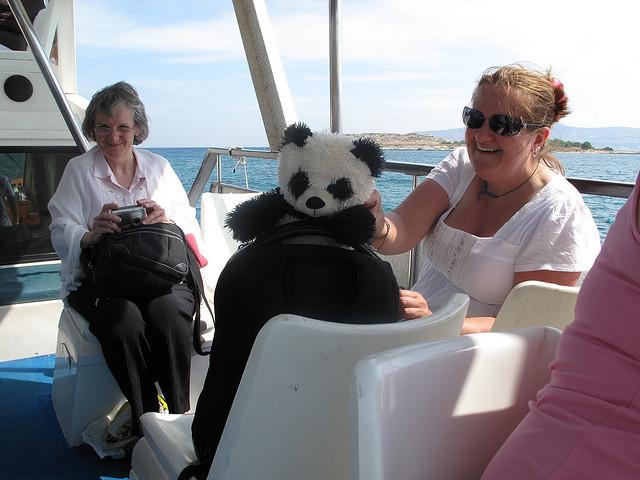What is the woman on the right holding?
Write a very short answer. Panda bear. Are they on a boat?
Concise answer only. Yes. Where are the woman in the picture?
Be succinct. On boat. 